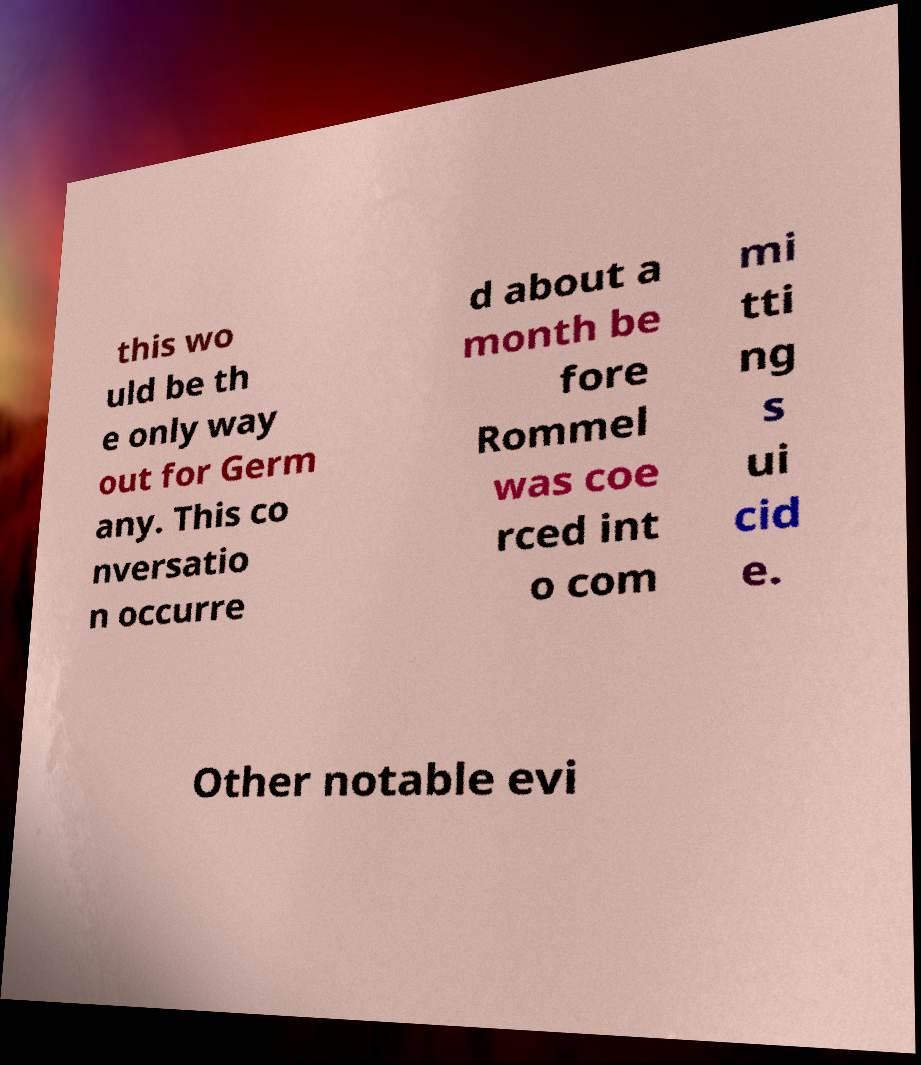Could you extract and type out the text from this image? this wo uld be th e only way out for Germ any. This co nversatio n occurre d about a month be fore Rommel was coe rced int o com mi tti ng s ui cid e. Other notable evi 